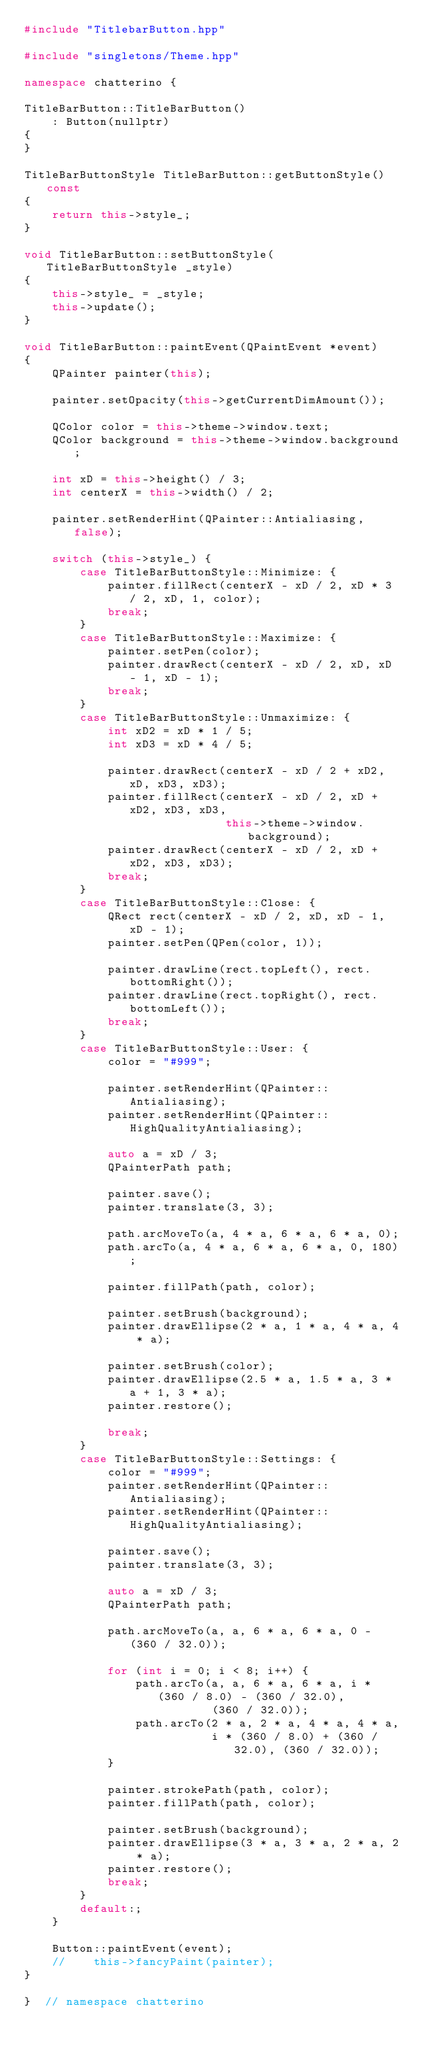Convert code to text. <code><loc_0><loc_0><loc_500><loc_500><_C++_>#include "TitlebarButton.hpp"

#include "singletons/Theme.hpp"

namespace chatterino {

TitleBarButton::TitleBarButton()
    : Button(nullptr)
{
}

TitleBarButtonStyle TitleBarButton::getButtonStyle() const
{
    return this->style_;
}

void TitleBarButton::setButtonStyle(TitleBarButtonStyle _style)
{
    this->style_ = _style;
    this->update();
}

void TitleBarButton::paintEvent(QPaintEvent *event)
{
    QPainter painter(this);

    painter.setOpacity(this->getCurrentDimAmount());

    QColor color = this->theme->window.text;
    QColor background = this->theme->window.background;

    int xD = this->height() / 3;
    int centerX = this->width() / 2;

    painter.setRenderHint(QPainter::Antialiasing, false);

    switch (this->style_) {
        case TitleBarButtonStyle::Minimize: {
            painter.fillRect(centerX - xD / 2, xD * 3 / 2, xD, 1, color);
            break;
        }
        case TitleBarButtonStyle::Maximize: {
            painter.setPen(color);
            painter.drawRect(centerX - xD / 2, xD, xD - 1, xD - 1);
            break;
        }
        case TitleBarButtonStyle::Unmaximize: {
            int xD2 = xD * 1 / 5;
            int xD3 = xD * 4 / 5;

            painter.drawRect(centerX - xD / 2 + xD2, xD, xD3, xD3);
            painter.fillRect(centerX - xD / 2, xD + xD2, xD3, xD3,
                             this->theme->window.background);
            painter.drawRect(centerX - xD / 2, xD + xD2, xD3, xD3);
            break;
        }
        case TitleBarButtonStyle::Close: {
            QRect rect(centerX - xD / 2, xD, xD - 1, xD - 1);
            painter.setPen(QPen(color, 1));

            painter.drawLine(rect.topLeft(), rect.bottomRight());
            painter.drawLine(rect.topRight(), rect.bottomLeft());
            break;
        }
        case TitleBarButtonStyle::User: {
            color = "#999";

            painter.setRenderHint(QPainter::Antialiasing);
            painter.setRenderHint(QPainter::HighQualityAntialiasing);

            auto a = xD / 3;
            QPainterPath path;

            painter.save();
            painter.translate(3, 3);

            path.arcMoveTo(a, 4 * a, 6 * a, 6 * a, 0);
            path.arcTo(a, 4 * a, 6 * a, 6 * a, 0, 180);

            painter.fillPath(path, color);

            painter.setBrush(background);
            painter.drawEllipse(2 * a, 1 * a, 4 * a, 4 * a);

            painter.setBrush(color);
            painter.drawEllipse(2.5 * a, 1.5 * a, 3 * a + 1, 3 * a);
            painter.restore();

            break;
        }
        case TitleBarButtonStyle::Settings: {
            color = "#999";
            painter.setRenderHint(QPainter::Antialiasing);
            painter.setRenderHint(QPainter::HighQualityAntialiasing);

            painter.save();
            painter.translate(3, 3);

            auto a = xD / 3;
            QPainterPath path;

            path.arcMoveTo(a, a, 6 * a, 6 * a, 0 - (360 / 32.0));

            for (int i = 0; i < 8; i++) {
                path.arcTo(a, a, 6 * a, 6 * a, i * (360 / 8.0) - (360 / 32.0),
                           (360 / 32.0));
                path.arcTo(2 * a, 2 * a, 4 * a, 4 * a,
                           i * (360 / 8.0) + (360 / 32.0), (360 / 32.0));
            }

            painter.strokePath(path, color);
            painter.fillPath(path, color);

            painter.setBrush(background);
            painter.drawEllipse(3 * a, 3 * a, 2 * a, 2 * a);
            painter.restore();
            break;
        }
        default:;
    }

    Button::paintEvent(event);
    //    this->fancyPaint(painter);
}

}  // namespace chatterino
</code> 